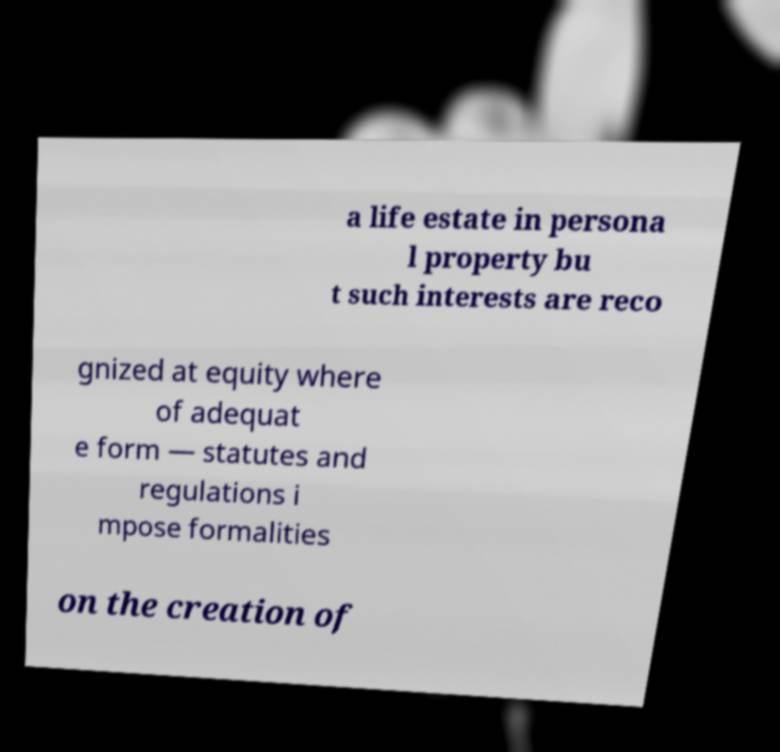What messages or text are displayed in this image? I need them in a readable, typed format. a life estate in persona l property bu t such interests are reco gnized at equity where of adequat e form — statutes and regulations i mpose formalities on the creation of 